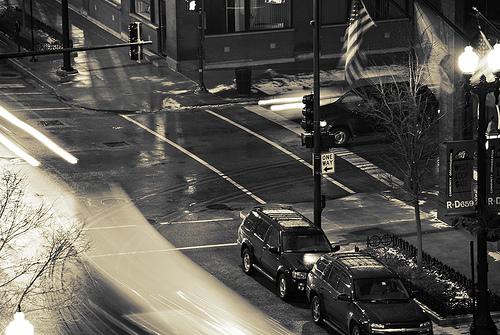What is the weather like?
Be succinct. Rainy. What does the white sign say?
Short answer required. One way. For these conditions, which feature of these vehicles is most crucial?
Be succinct. Brakes. 